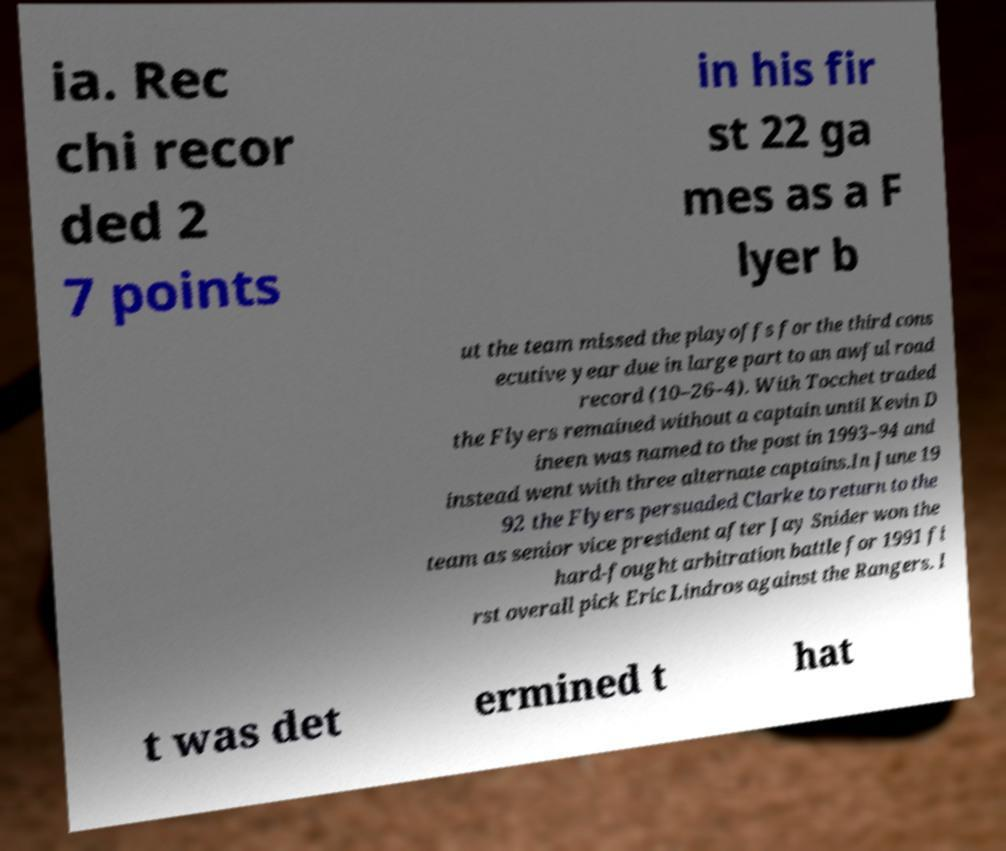What messages or text are displayed in this image? I need them in a readable, typed format. ia. Rec chi recor ded 2 7 points in his fir st 22 ga mes as a F lyer b ut the team missed the playoffs for the third cons ecutive year due in large part to an awful road record (10–26–4). With Tocchet traded the Flyers remained without a captain until Kevin D ineen was named to the post in 1993–94 and instead went with three alternate captains.In June 19 92 the Flyers persuaded Clarke to return to the team as senior vice president after Jay Snider won the hard-fought arbitration battle for 1991 fi rst overall pick Eric Lindros against the Rangers. I t was det ermined t hat 